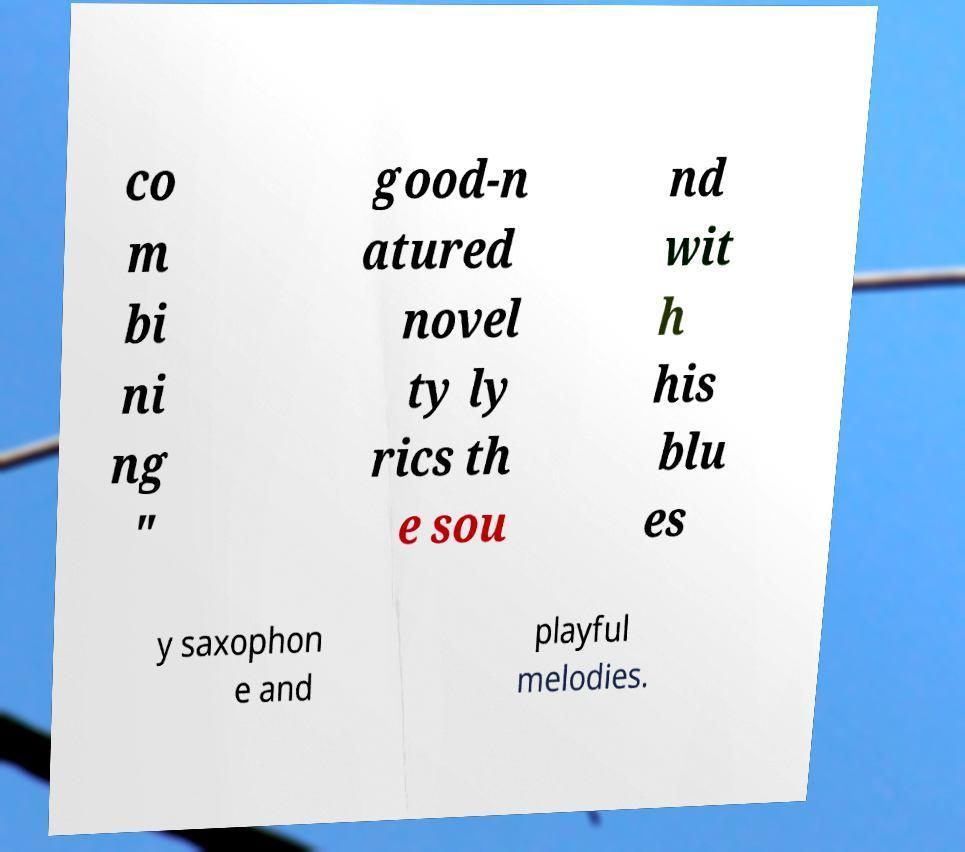Could you extract and type out the text from this image? co m bi ni ng " good-n atured novel ty ly rics th e sou nd wit h his blu es y saxophon e and playful melodies. 